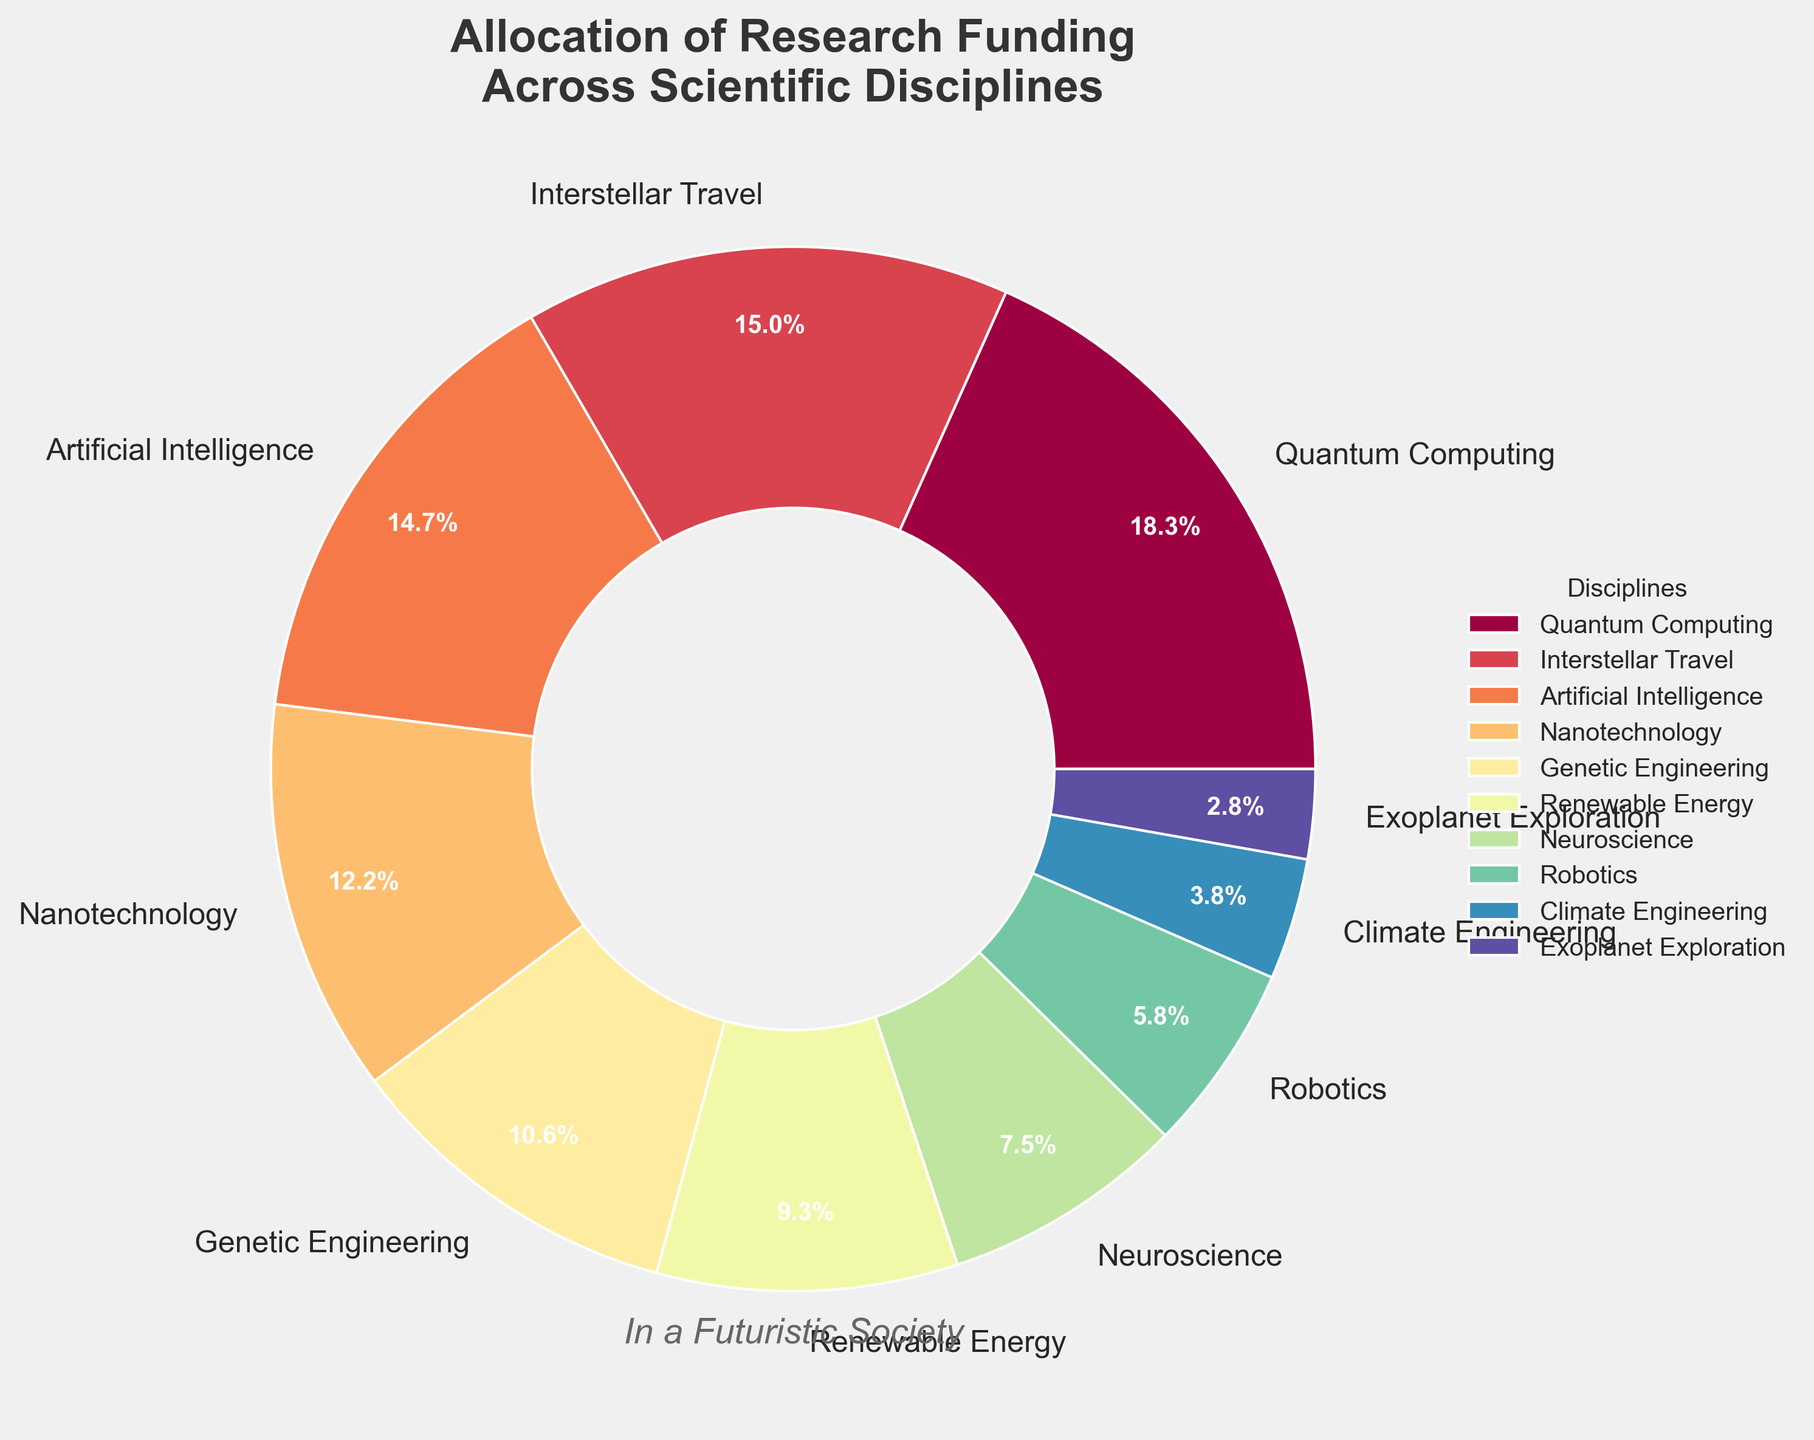What is the discipline with the highest funding percentage? The pie chart shows each discipline labeled with its funding percentage. By comparing the percentages, we can identify that Quantum Computing has the highest funding percentage.
Answer: Quantum Computing Which two disciplines combined receive the same funding percentage as Quantum Computing? By examining percentages, we find that Quantum Computing receives 18.5%. Adding the funding for Interstellar Travel (15.2%) and Exoplanet Exploration (2.8%) equals Quantum Computing’s funding percentage (15.2 + 2.8 = 18.0, which is very close but not sufficient). Instead, Artificial Intelligence (14.8%) and Climate Engineering (3.8%) together make 18.6%, almost equivalent.
Answer: Artificial Intelligence and Climate Engineering Which disciplines receive more funding than Genetic Engineering? Genetic Engineering receives 10.7%. By scanning the pie chart, disciplines with higher percentages are Quantum Computing (18.5%), Interstellar Travel (15.2%), Artificial Intelligence (14.8%), and Nanotechnology (12.3%).
Answer: Quantum Computing, Interstellar Travel, Artificial Intelligence, and Nanotechnology What is the visual attribute of the discipline with the lowest funding percentage? Exoplanet Exploration is marked with the lowest funding percentage (2.8%). The pie chart section for Exoplanet Exploration would visually appear as the smallest wedge.
Answer: Smallest wedge How much more funding does Quantum Computing receive compared to Neuroscience? Find Quantum Computing (18.5%) and Neuroscience (7.6%) on the chart. Subtract Neuroscience’s percentage from Quantum Computing's (18.5 - 7.6 = 10.9).
Answer: 10.9 What proportion of the chart is dedicated to Nanotechnology? The percentage of the entire chart dedicated to Nanotechnology, as labeled, is 12.3%.
Answer: 12.3% How does the funding for Renewable Energy compare visually to Genetic Engineering? Renewable Energy has a slighly smaller wedge than Genetic Engineering, 9.4% compared to the 10.7% of Genetic Engineering, making Renewable Energy visually smaller though not significantly.
Answer: Smaller wedge Which discipline category falls between Artificial Intelligence and Nanotechnology in funding percentage? Checking the chart, after Artificial Intelligence (14.8%), the next lower percentage is Nanotechnology (12.3%). No discipline falls directly in between these two in terms of funding.
Answer: None 